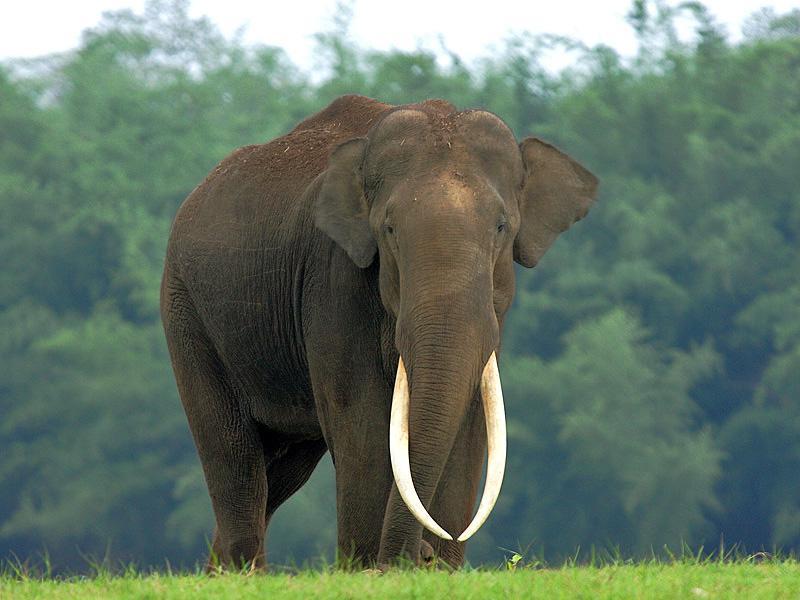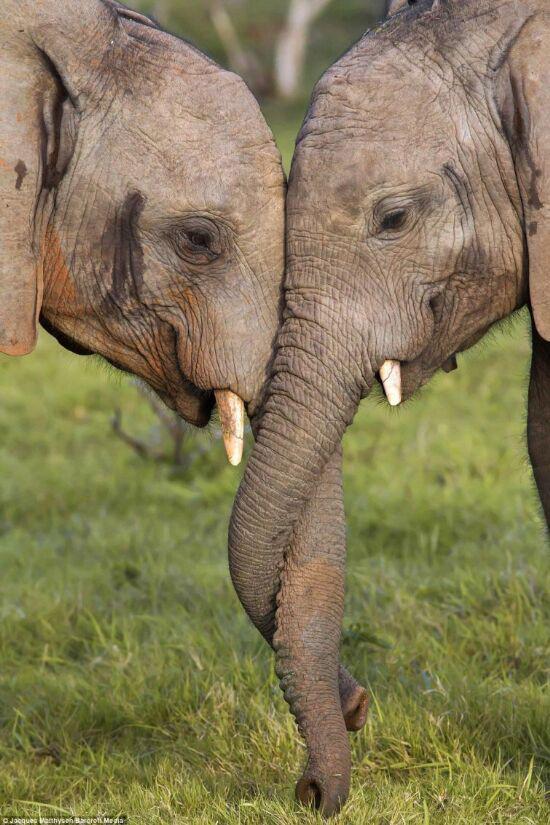The first image is the image on the left, the second image is the image on the right. Assess this claim about the two images: "There are no more than three elephants". Correct or not? Answer yes or no. Yes. 